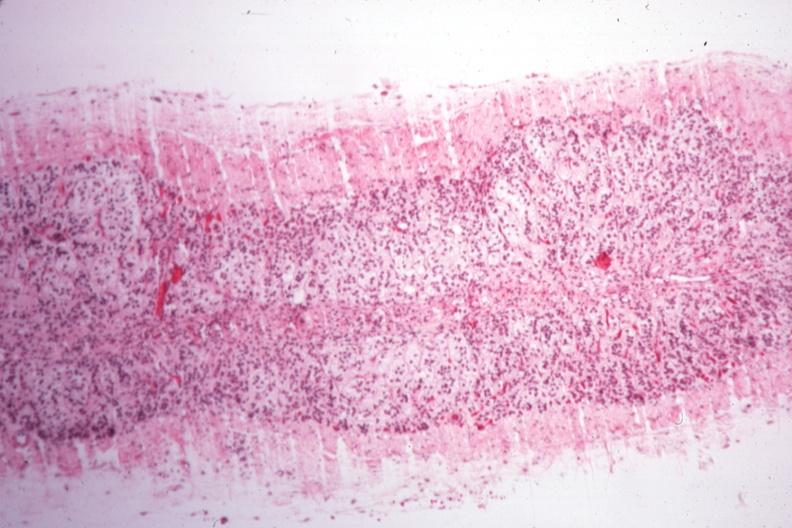s atrophy secondary to pituitectomy present?
Answer the question using a single word or phrase. Yes 